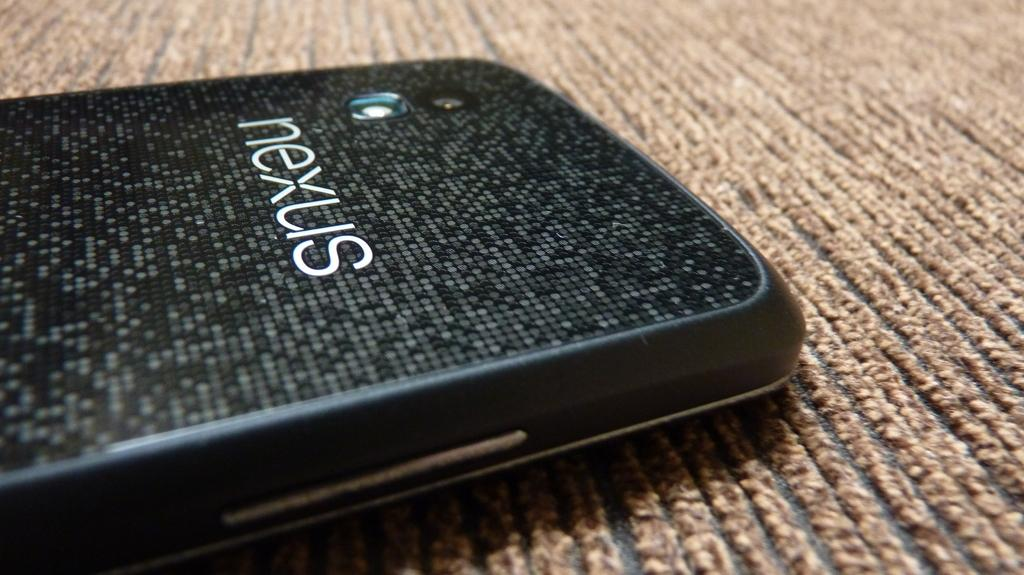What electronic device is present in the image? There is a mobile phone in the image. Where is the mobile phone located? The mobile phone is placed on the floor. What information is displayed on the mobile phone? The mobile phone has a name displayed on it. What feature is available on the mobile phone? The mobile phone has a camera feature. What can be seen on the mobile phone's surface? The buttons on the mobile phone are visible. How many sisters are playing with the mobile phone in the image? There are no sisters present in the image; it only features a mobile phone placed on the floor. 